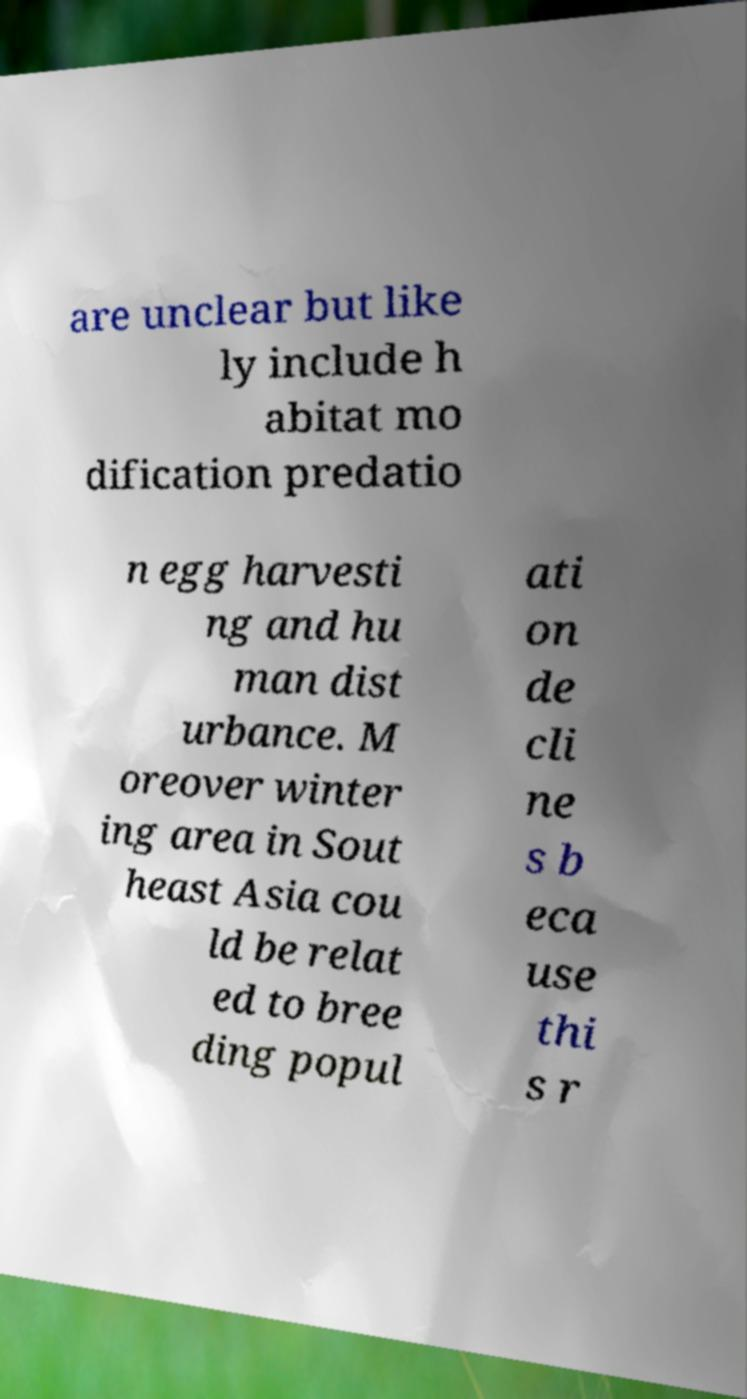Can you accurately transcribe the text from the provided image for me? are unclear but like ly include h abitat mo dification predatio n egg harvesti ng and hu man dist urbance. M oreover winter ing area in Sout heast Asia cou ld be relat ed to bree ding popul ati on de cli ne s b eca use thi s r 